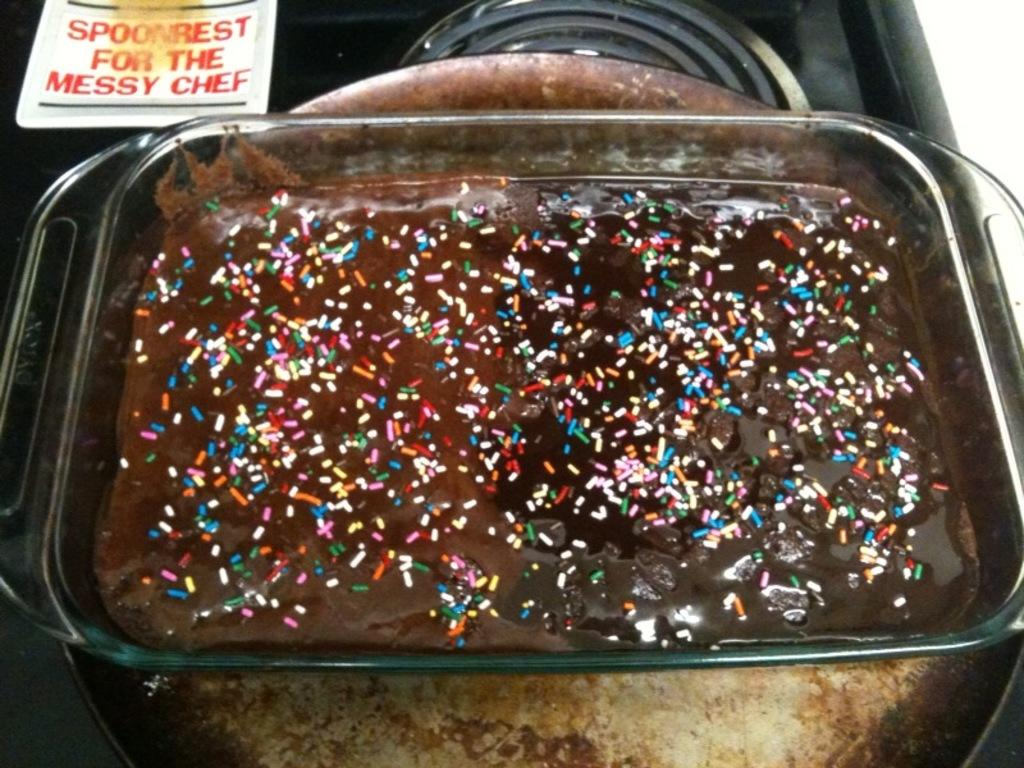What type of objects can be seen in the image? There is food and a name card in the image. Can you describe the containers in the image? There are bowls in the image. What type of rod is being used to stir the food in the image? There is no rod visible in the image; it only shows food, a name card, and bowls. 